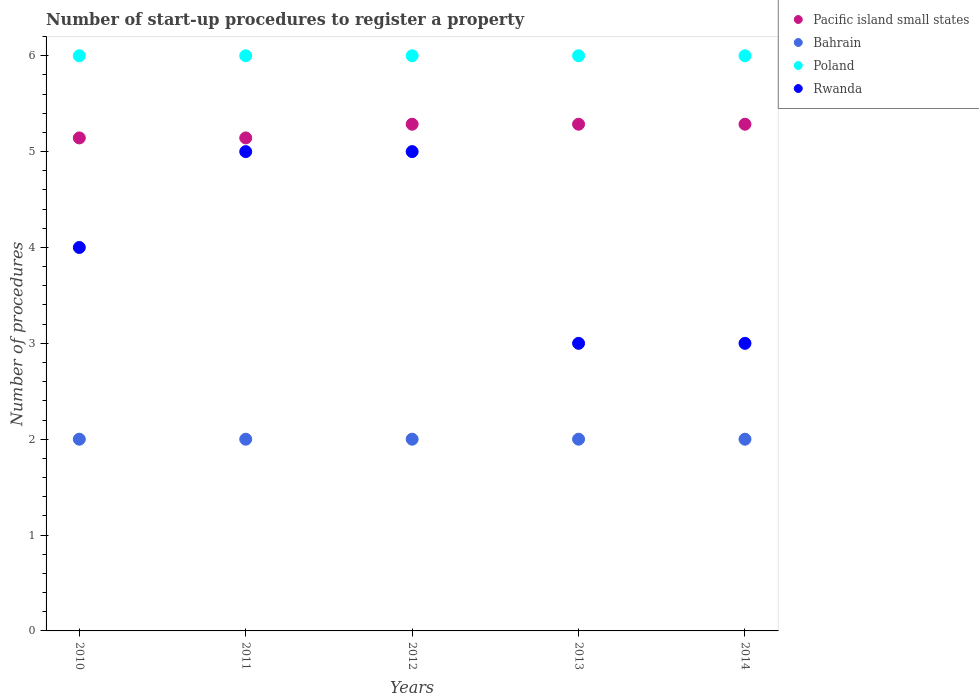Is the number of dotlines equal to the number of legend labels?
Provide a succinct answer. Yes. What is the number of procedures required to register a property in Bahrain in 2012?
Your answer should be compact. 2. Across all years, what is the minimum number of procedures required to register a property in Rwanda?
Your answer should be very brief. 3. What is the total number of procedures required to register a property in Rwanda in the graph?
Provide a succinct answer. 20. What is the difference between the number of procedures required to register a property in Pacific island small states in 2010 and that in 2012?
Give a very brief answer. -0.14. What is the difference between the number of procedures required to register a property in Rwanda in 2014 and the number of procedures required to register a property in Bahrain in 2012?
Provide a short and direct response. 1. In how many years, is the number of procedures required to register a property in Rwanda greater than 2?
Give a very brief answer. 5. What is the ratio of the number of procedures required to register a property in Pacific island small states in 2011 to that in 2013?
Keep it short and to the point. 0.97. Is the number of procedures required to register a property in Rwanda in 2010 less than that in 2012?
Give a very brief answer. Yes. What is the difference between the highest and the lowest number of procedures required to register a property in Rwanda?
Offer a very short reply. 2. In how many years, is the number of procedures required to register a property in Poland greater than the average number of procedures required to register a property in Poland taken over all years?
Provide a succinct answer. 0. Is it the case that in every year, the sum of the number of procedures required to register a property in Rwanda and number of procedures required to register a property in Pacific island small states  is greater than the number of procedures required to register a property in Poland?
Your response must be concise. Yes. Does the number of procedures required to register a property in Poland monotonically increase over the years?
Keep it short and to the point. No. Is the number of procedures required to register a property in Bahrain strictly greater than the number of procedures required to register a property in Pacific island small states over the years?
Your answer should be compact. No. Is the number of procedures required to register a property in Bahrain strictly less than the number of procedures required to register a property in Poland over the years?
Ensure brevity in your answer.  Yes. How many years are there in the graph?
Give a very brief answer. 5. Are the values on the major ticks of Y-axis written in scientific E-notation?
Ensure brevity in your answer.  No. Does the graph contain any zero values?
Keep it short and to the point. No. Does the graph contain grids?
Offer a terse response. No. Where does the legend appear in the graph?
Offer a terse response. Top right. How many legend labels are there?
Offer a terse response. 4. What is the title of the graph?
Offer a terse response. Number of start-up procedures to register a property. Does "New Caledonia" appear as one of the legend labels in the graph?
Your answer should be very brief. No. What is the label or title of the X-axis?
Your response must be concise. Years. What is the label or title of the Y-axis?
Offer a terse response. Number of procedures. What is the Number of procedures in Pacific island small states in 2010?
Offer a very short reply. 5.14. What is the Number of procedures in Bahrain in 2010?
Your answer should be very brief. 2. What is the Number of procedures of Rwanda in 2010?
Give a very brief answer. 4. What is the Number of procedures in Pacific island small states in 2011?
Provide a succinct answer. 5.14. What is the Number of procedures of Rwanda in 2011?
Make the answer very short. 5. What is the Number of procedures of Pacific island small states in 2012?
Offer a very short reply. 5.29. What is the Number of procedures in Pacific island small states in 2013?
Provide a short and direct response. 5.29. What is the Number of procedures of Pacific island small states in 2014?
Provide a short and direct response. 5.29. What is the Number of procedures in Poland in 2014?
Keep it short and to the point. 6. Across all years, what is the maximum Number of procedures of Pacific island small states?
Your answer should be compact. 5.29. Across all years, what is the maximum Number of procedures of Bahrain?
Give a very brief answer. 2. Across all years, what is the minimum Number of procedures in Pacific island small states?
Your answer should be compact. 5.14. Across all years, what is the minimum Number of procedures of Rwanda?
Offer a terse response. 3. What is the total Number of procedures in Pacific island small states in the graph?
Give a very brief answer. 26.14. What is the total Number of procedures in Bahrain in the graph?
Offer a terse response. 10. What is the difference between the Number of procedures in Pacific island small states in 2010 and that in 2011?
Make the answer very short. 0. What is the difference between the Number of procedures in Rwanda in 2010 and that in 2011?
Your answer should be very brief. -1. What is the difference between the Number of procedures of Pacific island small states in 2010 and that in 2012?
Offer a very short reply. -0.14. What is the difference between the Number of procedures of Bahrain in 2010 and that in 2012?
Offer a terse response. 0. What is the difference between the Number of procedures of Poland in 2010 and that in 2012?
Ensure brevity in your answer.  0. What is the difference between the Number of procedures in Rwanda in 2010 and that in 2012?
Provide a short and direct response. -1. What is the difference between the Number of procedures in Pacific island small states in 2010 and that in 2013?
Make the answer very short. -0.14. What is the difference between the Number of procedures in Rwanda in 2010 and that in 2013?
Give a very brief answer. 1. What is the difference between the Number of procedures of Pacific island small states in 2010 and that in 2014?
Provide a short and direct response. -0.14. What is the difference between the Number of procedures of Bahrain in 2010 and that in 2014?
Your response must be concise. 0. What is the difference between the Number of procedures of Pacific island small states in 2011 and that in 2012?
Ensure brevity in your answer.  -0.14. What is the difference between the Number of procedures of Bahrain in 2011 and that in 2012?
Provide a short and direct response. 0. What is the difference between the Number of procedures of Rwanda in 2011 and that in 2012?
Provide a short and direct response. 0. What is the difference between the Number of procedures of Pacific island small states in 2011 and that in 2013?
Give a very brief answer. -0.14. What is the difference between the Number of procedures of Bahrain in 2011 and that in 2013?
Your answer should be compact. 0. What is the difference between the Number of procedures of Rwanda in 2011 and that in 2013?
Your response must be concise. 2. What is the difference between the Number of procedures in Pacific island small states in 2011 and that in 2014?
Provide a short and direct response. -0.14. What is the difference between the Number of procedures of Rwanda in 2011 and that in 2014?
Make the answer very short. 2. What is the difference between the Number of procedures of Bahrain in 2012 and that in 2013?
Make the answer very short. 0. What is the difference between the Number of procedures of Pacific island small states in 2012 and that in 2014?
Your answer should be very brief. 0. What is the difference between the Number of procedures of Pacific island small states in 2013 and that in 2014?
Your answer should be compact. 0. What is the difference between the Number of procedures in Pacific island small states in 2010 and the Number of procedures in Bahrain in 2011?
Keep it short and to the point. 3.14. What is the difference between the Number of procedures of Pacific island small states in 2010 and the Number of procedures of Poland in 2011?
Offer a very short reply. -0.86. What is the difference between the Number of procedures in Pacific island small states in 2010 and the Number of procedures in Rwanda in 2011?
Give a very brief answer. 0.14. What is the difference between the Number of procedures in Pacific island small states in 2010 and the Number of procedures in Bahrain in 2012?
Offer a terse response. 3.14. What is the difference between the Number of procedures in Pacific island small states in 2010 and the Number of procedures in Poland in 2012?
Offer a very short reply. -0.86. What is the difference between the Number of procedures of Pacific island small states in 2010 and the Number of procedures of Rwanda in 2012?
Make the answer very short. 0.14. What is the difference between the Number of procedures of Bahrain in 2010 and the Number of procedures of Poland in 2012?
Provide a succinct answer. -4. What is the difference between the Number of procedures of Bahrain in 2010 and the Number of procedures of Rwanda in 2012?
Your answer should be very brief. -3. What is the difference between the Number of procedures in Poland in 2010 and the Number of procedures in Rwanda in 2012?
Make the answer very short. 1. What is the difference between the Number of procedures of Pacific island small states in 2010 and the Number of procedures of Bahrain in 2013?
Make the answer very short. 3.14. What is the difference between the Number of procedures in Pacific island small states in 2010 and the Number of procedures in Poland in 2013?
Your response must be concise. -0.86. What is the difference between the Number of procedures in Pacific island small states in 2010 and the Number of procedures in Rwanda in 2013?
Your answer should be compact. 2.14. What is the difference between the Number of procedures in Bahrain in 2010 and the Number of procedures in Poland in 2013?
Provide a succinct answer. -4. What is the difference between the Number of procedures of Pacific island small states in 2010 and the Number of procedures of Bahrain in 2014?
Your answer should be compact. 3.14. What is the difference between the Number of procedures in Pacific island small states in 2010 and the Number of procedures in Poland in 2014?
Provide a short and direct response. -0.86. What is the difference between the Number of procedures of Pacific island small states in 2010 and the Number of procedures of Rwanda in 2014?
Your answer should be very brief. 2.14. What is the difference between the Number of procedures of Bahrain in 2010 and the Number of procedures of Poland in 2014?
Give a very brief answer. -4. What is the difference between the Number of procedures of Bahrain in 2010 and the Number of procedures of Rwanda in 2014?
Provide a succinct answer. -1. What is the difference between the Number of procedures in Pacific island small states in 2011 and the Number of procedures in Bahrain in 2012?
Provide a succinct answer. 3.14. What is the difference between the Number of procedures in Pacific island small states in 2011 and the Number of procedures in Poland in 2012?
Your answer should be compact. -0.86. What is the difference between the Number of procedures of Pacific island small states in 2011 and the Number of procedures of Rwanda in 2012?
Make the answer very short. 0.14. What is the difference between the Number of procedures of Pacific island small states in 2011 and the Number of procedures of Bahrain in 2013?
Your response must be concise. 3.14. What is the difference between the Number of procedures of Pacific island small states in 2011 and the Number of procedures of Poland in 2013?
Make the answer very short. -0.86. What is the difference between the Number of procedures of Pacific island small states in 2011 and the Number of procedures of Rwanda in 2013?
Your answer should be compact. 2.14. What is the difference between the Number of procedures in Bahrain in 2011 and the Number of procedures in Poland in 2013?
Your answer should be very brief. -4. What is the difference between the Number of procedures of Bahrain in 2011 and the Number of procedures of Rwanda in 2013?
Give a very brief answer. -1. What is the difference between the Number of procedures in Pacific island small states in 2011 and the Number of procedures in Bahrain in 2014?
Make the answer very short. 3.14. What is the difference between the Number of procedures in Pacific island small states in 2011 and the Number of procedures in Poland in 2014?
Your answer should be compact. -0.86. What is the difference between the Number of procedures in Pacific island small states in 2011 and the Number of procedures in Rwanda in 2014?
Your answer should be compact. 2.14. What is the difference between the Number of procedures of Bahrain in 2011 and the Number of procedures of Poland in 2014?
Give a very brief answer. -4. What is the difference between the Number of procedures in Bahrain in 2011 and the Number of procedures in Rwanda in 2014?
Your answer should be compact. -1. What is the difference between the Number of procedures in Pacific island small states in 2012 and the Number of procedures in Bahrain in 2013?
Your answer should be very brief. 3.29. What is the difference between the Number of procedures in Pacific island small states in 2012 and the Number of procedures in Poland in 2013?
Your response must be concise. -0.71. What is the difference between the Number of procedures in Pacific island small states in 2012 and the Number of procedures in Rwanda in 2013?
Keep it short and to the point. 2.29. What is the difference between the Number of procedures in Bahrain in 2012 and the Number of procedures in Rwanda in 2013?
Offer a terse response. -1. What is the difference between the Number of procedures in Poland in 2012 and the Number of procedures in Rwanda in 2013?
Provide a succinct answer. 3. What is the difference between the Number of procedures of Pacific island small states in 2012 and the Number of procedures of Bahrain in 2014?
Make the answer very short. 3.29. What is the difference between the Number of procedures in Pacific island small states in 2012 and the Number of procedures in Poland in 2014?
Your response must be concise. -0.71. What is the difference between the Number of procedures of Pacific island small states in 2012 and the Number of procedures of Rwanda in 2014?
Provide a succinct answer. 2.29. What is the difference between the Number of procedures of Bahrain in 2012 and the Number of procedures of Poland in 2014?
Your answer should be compact. -4. What is the difference between the Number of procedures of Bahrain in 2012 and the Number of procedures of Rwanda in 2014?
Your answer should be very brief. -1. What is the difference between the Number of procedures of Poland in 2012 and the Number of procedures of Rwanda in 2014?
Your answer should be very brief. 3. What is the difference between the Number of procedures in Pacific island small states in 2013 and the Number of procedures in Bahrain in 2014?
Your response must be concise. 3.29. What is the difference between the Number of procedures in Pacific island small states in 2013 and the Number of procedures in Poland in 2014?
Your answer should be very brief. -0.71. What is the difference between the Number of procedures of Pacific island small states in 2013 and the Number of procedures of Rwanda in 2014?
Make the answer very short. 2.29. What is the average Number of procedures in Pacific island small states per year?
Give a very brief answer. 5.23. What is the average Number of procedures of Bahrain per year?
Your response must be concise. 2. What is the average Number of procedures in Poland per year?
Keep it short and to the point. 6. In the year 2010, what is the difference between the Number of procedures in Pacific island small states and Number of procedures in Bahrain?
Your response must be concise. 3.14. In the year 2010, what is the difference between the Number of procedures in Pacific island small states and Number of procedures in Poland?
Provide a succinct answer. -0.86. In the year 2010, what is the difference between the Number of procedures of Bahrain and Number of procedures of Rwanda?
Keep it short and to the point. -2. In the year 2011, what is the difference between the Number of procedures in Pacific island small states and Number of procedures in Bahrain?
Your answer should be very brief. 3.14. In the year 2011, what is the difference between the Number of procedures in Pacific island small states and Number of procedures in Poland?
Make the answer very short. -0.86. In the year 2011, what is the difference between the Number of procedures in Pacific island small states and Number of procedures in Rwanda?
Give a very brief answer. 0.14. In the year 2011, what is the difference between the Number of procedures of Bahrain and Number of procedures of Poland?
Your answer should be very brief. -4. In the year 2012, what is the difference between the Number of procedures in Pacific island small states and Number of procedures in Bahrain?
Provide a succinct answer. 3.29. In the year 2012, what is the difference between the Number of procedures in Pacific island small states and Number of procedures in Poland?
Offer a terse response. -0.71. In the year 2012, what is the difference between the Number of procedures of Pacific island small states and Number of procedures of Rwanda?
Offer a very short reply. 0.29. In the year 2013, what is the difference between the Number of procedures of Pacific island small states and Number of procedures of Bahrain?
Your response must be concise. 3.29. In the year 2013, what is the difference between the Number of procedures of Pacific island small states and Number of procedures of Poland?
Give a very brief answer. -0.71. In the year 2013, what is the difference between the Number of procedures of Pacific island small states and Number of procedures of Rwanda?
Offer a very short reply. 2.29. In the year 2013, what is the difference between the Number of procedures in Bahrain and Number of procedures in Poland?
Your answer should be compact. -4. In the year 2013, what is the difference between the Number of procedures in Poland and Number of procedures in Rwanda?
Make the answer very short. 3. In the year 2014, what is the difference between the Number of procedures of Pacific island small states and Number of procedures of Bahrain?
Your answer should be very brief. 3.29. In the year 2014, what is the difference between the Number of procedures of Pacific island small states and Number of procedures of Poland?
Make the answer very short. -0.71. In the year 2014, what is the difference between the Number of procedures of Pacific island small states and Number of procedures of Rwanda?
Offer a very short reply. 2.29. In the year 2014, what is the difference between the Number of procedures in Bahrain and Number of procedures in Poland?
Your answer should be very brief. -4. In the year 2014, what is the difference between the Number of procedures in Poland and Number of procedures in Rwanda?
Make the answer very short. 3. What is the ratio of the Number of procedures of Bahrain in 2010 to that in 2011?
Your answer should be compact. 1. What is the ratio of the Number of procedures of Poland in 2010 to that in 2011?
Your answer should be compact. 1. What is the ratio of the Number of procedures of Rwanda in 2010 to that in 2011?
Provide a succinct answer. 0.8. What is the ratio of the Number of procedures in Pacific island small states in 2010 to that in 2012?
Provide a succinct answer. 0.97. What is the ratio of the Number of procedures in Bahrain in 2010 to that in 2012?
Make the answer very short. 1. What is the ratio of the Number of procedures of Poland in 2010 to that in 2012?
Offer a very short reply. 1. What is the ratio of the Number of procedures in Rwanda in 2010 to that in 2012?
Give a very brief answer. 0.8. What is the ratio of the Number of procedures of Bahrain in 2010 to that in 2013?
Ensure brevity in your answer.  1. What is the ratio of the Number of procedures of Poland in 2010 to that in 2013?
Your answer should be very brief. 1. What is the ratio of the Number of procedures of Rwanda in 2010 to that in 2013?
Keep it short and to the point. 1.33. What is the ratio of the Number of procedures of Pacific island small states in 2010 to that in 2014?
Offer a terse response. 0.97. What is the ratio of the Number of procedures in Poland in 2010 to that in 2014?
Keep it short and to the point. 1. What is the ratio of the Number of procedures in Bahrain in 2011 to that in 2012?
Make the answer very short. 1. What is the ratio of the Number of procedures of Poland in 2011 to that in 2012?
Keep it short and to the point. 1. What is the ratio of the Number of procedures in Rwanda in 2011 to that in 2012?
Make the answer very short. 1. What is the ratio of the Number of procedures in Pacific island small states in 2011 to that in 2013?
Your answer should be very brief. 0.97. What is the ratio of the Number of procedures in Bahrain in 2011 to that in 2013?
Provide a succinct answer. 1. What is the ratio of the Number of procedures of Pacific island small states in 2011 to that in 2014?
Your answer should be compact. 0.97. What is the ratio of the Number of procedures of Poland in 2011 to that in 2014?
Your response must be concise. 1. What is the ratio of the Number of procedures of Pacific island small states in 2012 to that in 2013?
Offer a terse response. 1. What is the ratio of the Number of procedures of Poland in 2012 to that in 2013?
Provide a short and direct response. 1. What is the ratio of the Number of procedures of Rwanda in 2012 to that in 2013?
Your response must be concise. 1.67. What is the ratio of the Number of procedures in Bahrain in 2012 to that in 2014?
Give a very brief answer. 1. What is the ratio of the Number of procedures of Rwanda in 2012 to that in 2014?
Keep it short and to the point. 1.67. What is the difference between the highest and the lowest Number of procedures of Pacific island small states?
Give a very brief answer. 0.14. What is the difference between the highest and the lowest Number of procedures of Bahrain?
Provide a succinct answer. 0. What is the difference between the highest and the lowest Number of procedures in Rwanda?
Keep it short and to the point. 2. 